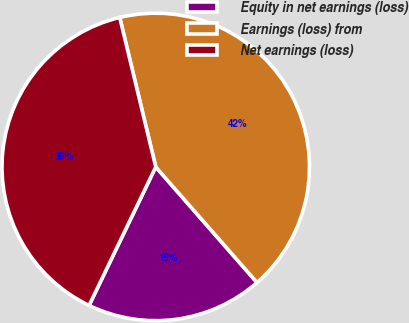Convert chart to OTSL. <chart><loc_0><loc_0><loc_500><loc_500><pie_chart><fcel>Equity in net earnings (loss)<fcel>Earnings (loss) from<fcel>Net earnings (loss)<nl><fcel>18.59%<fcel>42.32%<fcel>39.1%<nl></chart> 